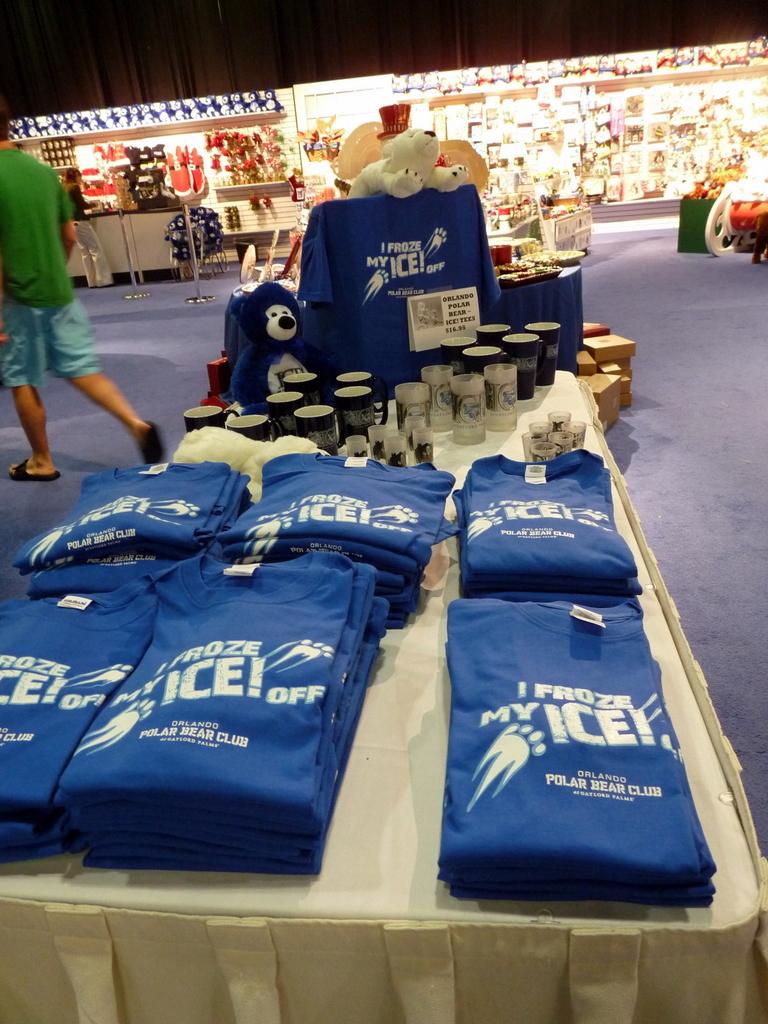What is on those shirts?
Provide a succinct answer. I froze my ice. What is wrote below the word ice?
Offer a terse response. Polar bear club. 